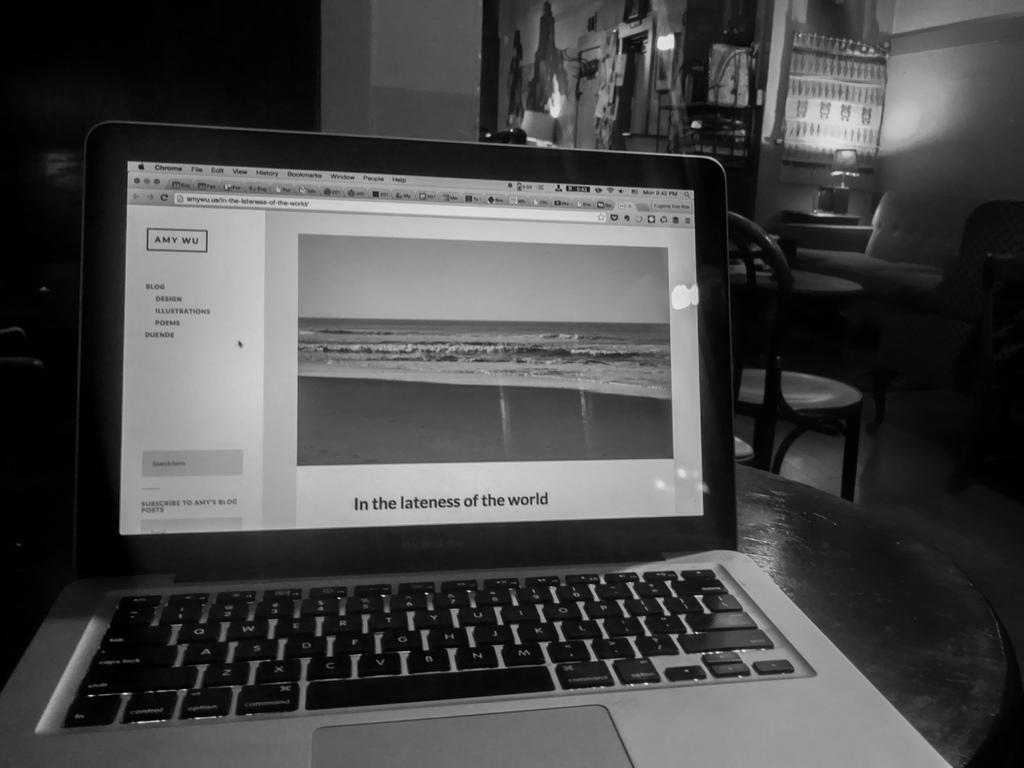<image>
Share a concise interpretation of the image provided. macbook laptop computer which lies open on the table 